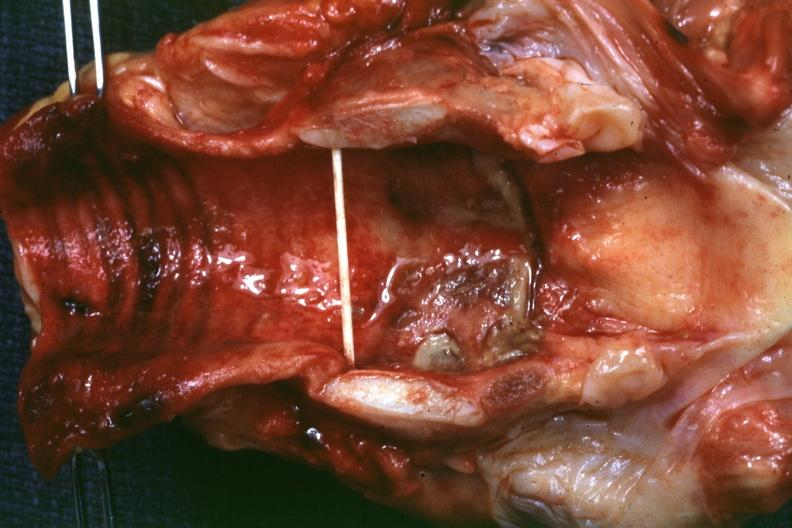s ulcer due to tube present?
Answer the question using a single word or phrase. Yes 